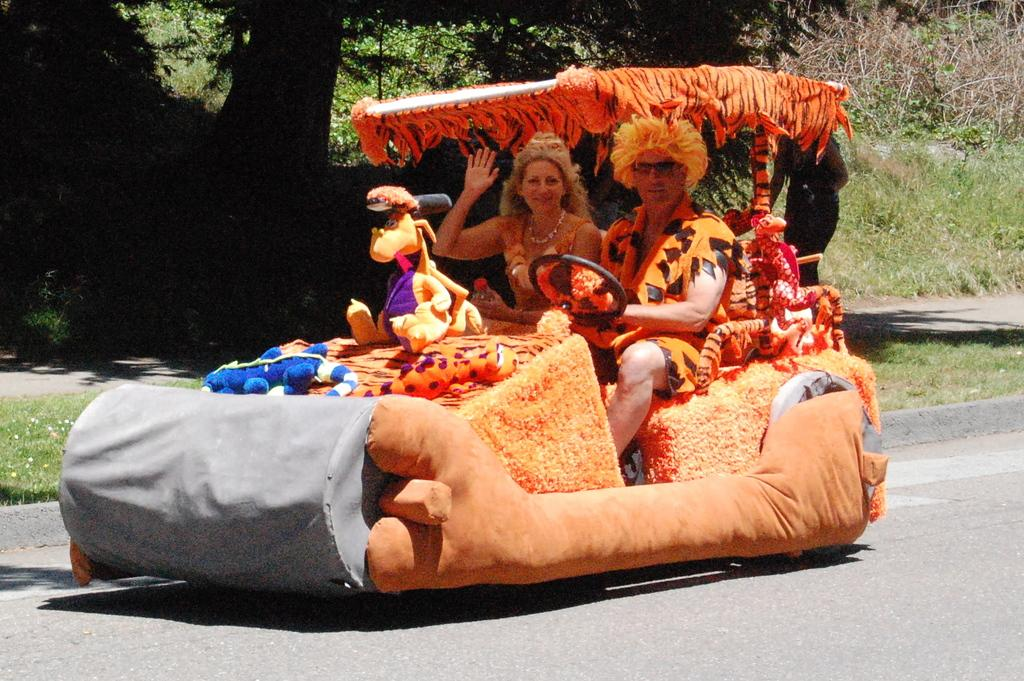What are the two persons in the image doing? The two persons are riding a vehicle on the road. Where is the vehicle located in the image? The vehicle is in the middle of the image. What is happening behind the vehicle? There is a person walking behind the vehicle. What can be seen in the background of the image? Trees and grass are visible in the background of the image. What type of plate is being used by the secretary in the image? There is no secretary or plate present in the image. What color is the paint on the vehicle in the image? The provided facts do not mention the color of the vehicle or any paint on it. 